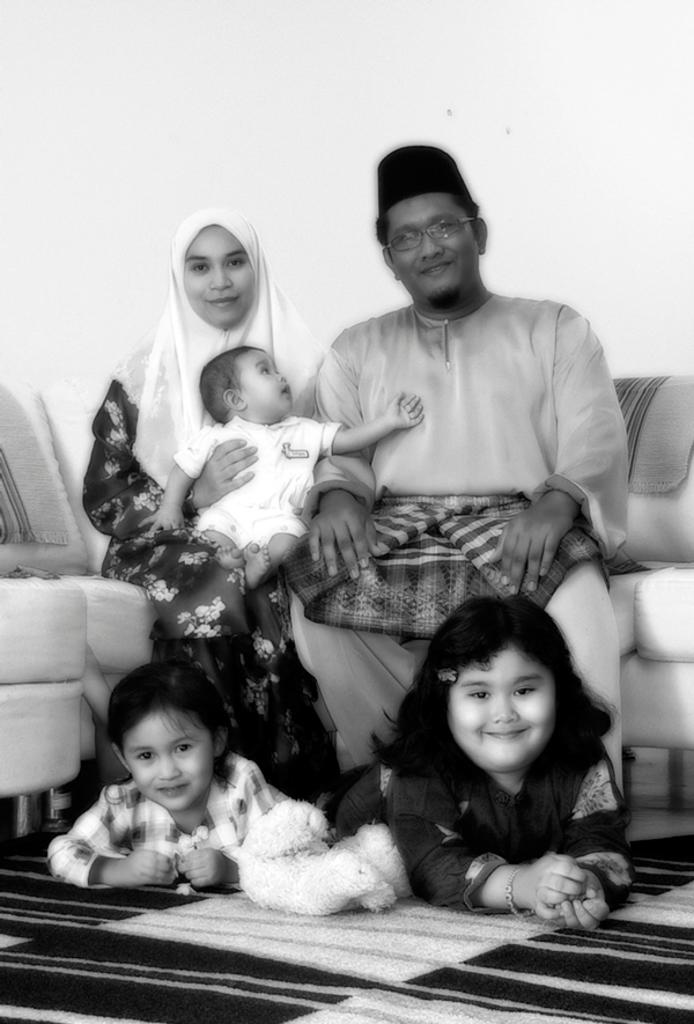How many people are sitting on the sofa in the image? There are two people sitting on the sofa in the image. What is the facial expression of the people on the sofa? The people on the sofa are smiling. How many girls are smiling in the image? There are two girls smiling in the image. What can be found on the carpet in the image? There is a toy on the carpet. Can you describe the relationship between the child and the woman in the image? There is a child on a woman in the image, suggesting that the child might be sitting on the woman's lap. What type of rose is the child holding in the image? There is no rose present in the image; it features a child on a woman and a toy on a carpet. 